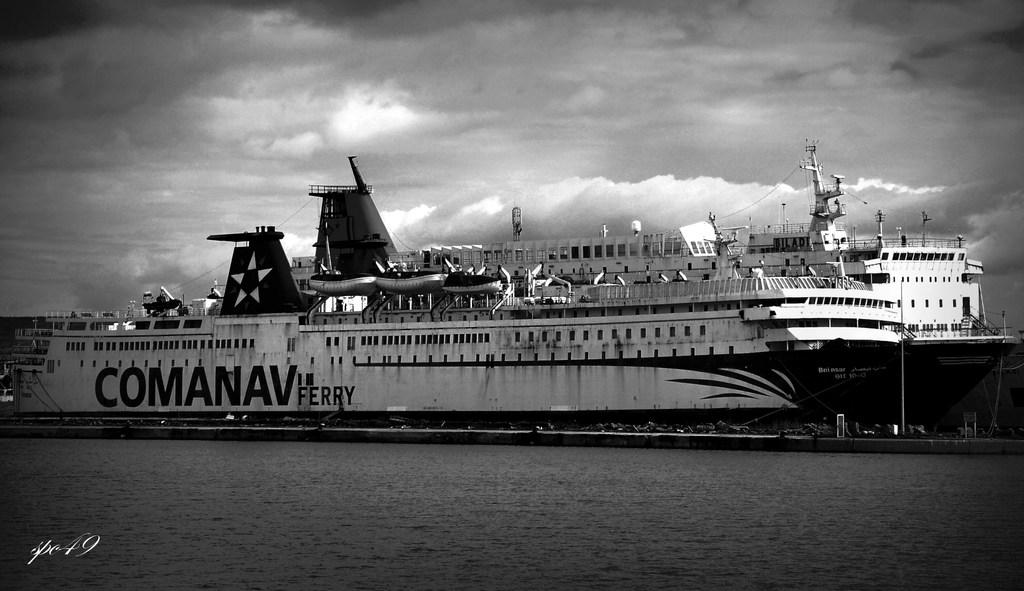What is the ship's name?
Keep it short and to the point. Comanav. Which company does the ferry belong to?
Make the answer very short. Comanav. 